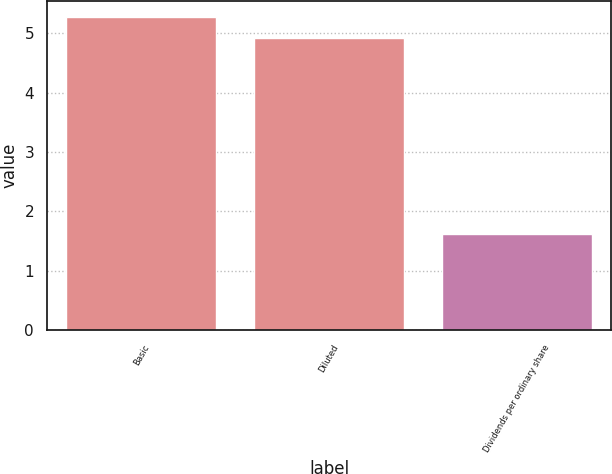Convert chart to OTSL. <chart><loc_0><loc_0><loc_500><loc_500><bar_chart><fcel>Basic<fcel>Diluted<fcel>Dividends per ordinary share<nl><fcel>5.28<fcel>4.93<fcel>1.62<nl></chart> 